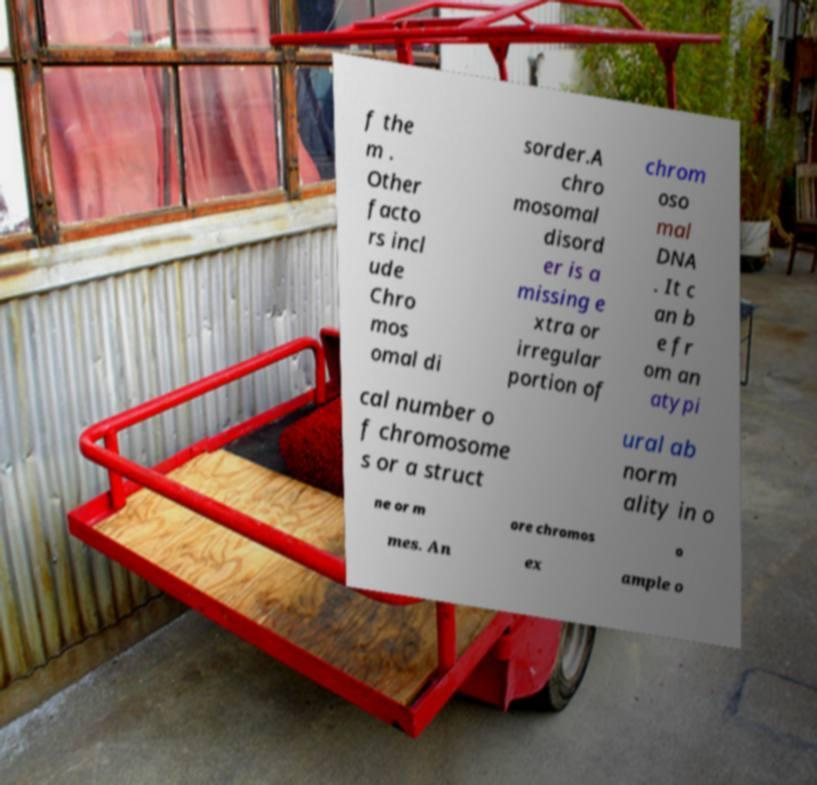For documentation purposes, I need the text within this image transcribed. Could you provide that? f the m . Other facto rs incl ude Chro mos omal di sorder.A chro mosomal disord er is a missing e xtra or irregular portion of chrom oso mal DNA . It c an b e fr om an atypi cal number o f chromosome s or a struct ural ab norm ality in o ne or m ore chromos o mes. An ex ample o 